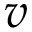<formula> <loc_0><loc_0><loc_500><loc_500>v</formula> 